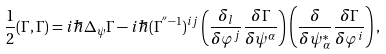<formula> <loc_0><loc_0><loc_500><loc_500>\frac { 1 } { 2 } ( \Gamma , \Gamma ) = i \hbar { \Delta } _ { \psi } \Gamma - i \hbar { ( } \Gamma ^ { ^ { \prime \prime } - 1 } ) ^ { i j } \left ( \frac { \delta _ { l } } { \delta \varphi ^ { j } } \frac { \delta \Gamma } { \delta \psi ^ { \alpha } } \right ) \left ( \frac { \delta } { \delta \psi ^ { * } _ { \alpha } } \frac { \delta \Gamma } { \delta \varphi ^ { i } } \right ) ,</formula> 